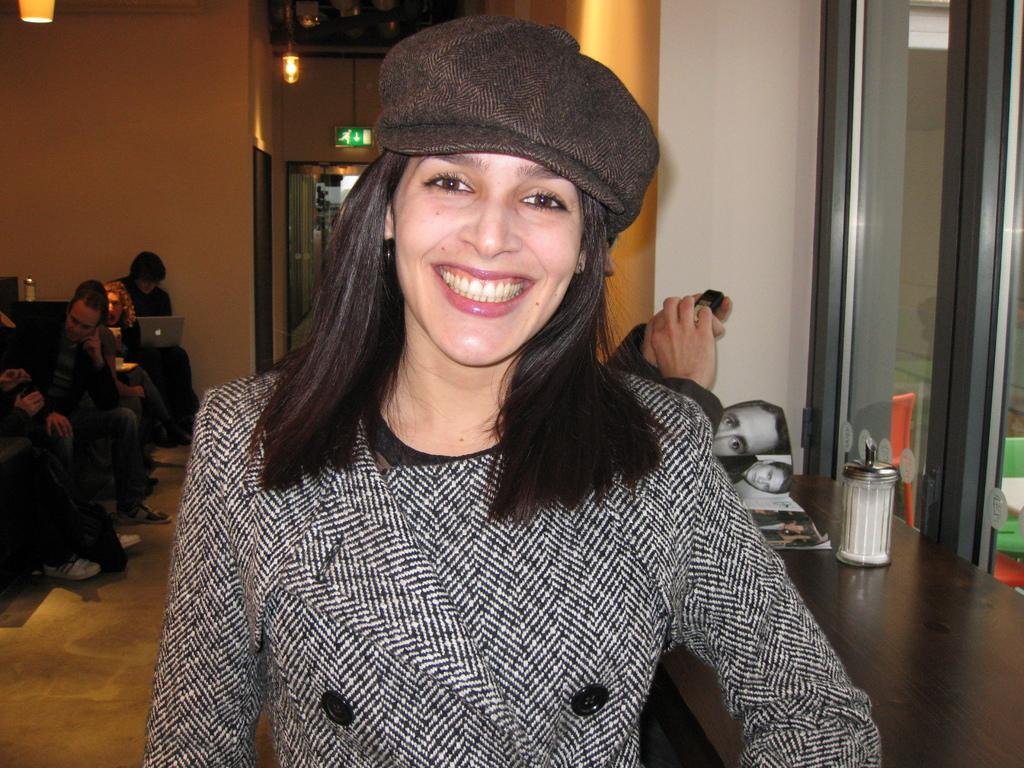What is the main subject of the image? There is a woman in the image. Can you describe the woman's appearance? The woman is wearing a cap and smiling. What can be seen in the background of the image? There are people, walls, lights, a laptop, jars, a book, a window, a direction board, and other objects in the background of the image. How many objects can be seen in the background of the image? There are at least 10 objects visible in the background of the image. What might the woman be doing in the image? It is not clear from the image what the woman is doing, but she appears to be in a public or shared space. Can you describe the kick of the brick in the image? There is no brick or kick present in the image. What type of servant is attending to the woman in the image? There is no servant present in the image. 